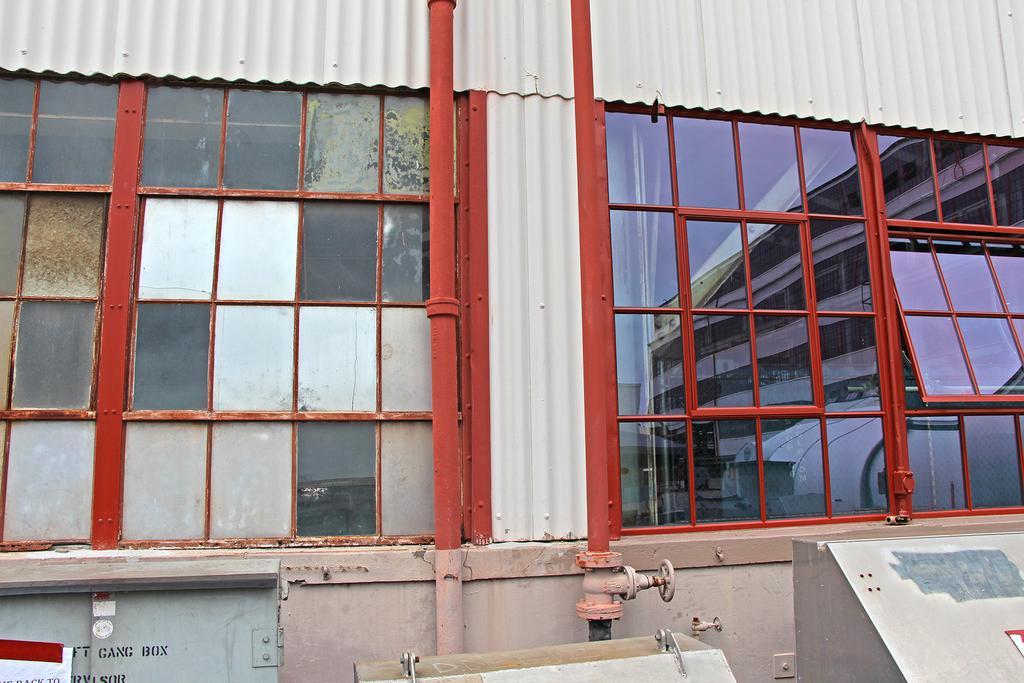Please provide a concise description of this image. In the image there are many windows to a compartment and there are two rods and there is a tap attached to one of the rod. There are some objects in front of that compartment wall. 